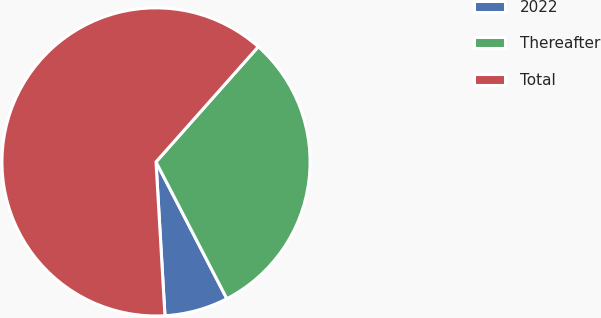<chart> <loc_0><loc_0><loc_500><loc_500><pie_chart><fcel>2022<fcel>Thereafter<fcel>Total<nl><fcel>6.68%<fcel>30.84%<fcel>62.48%<nl></chart> 